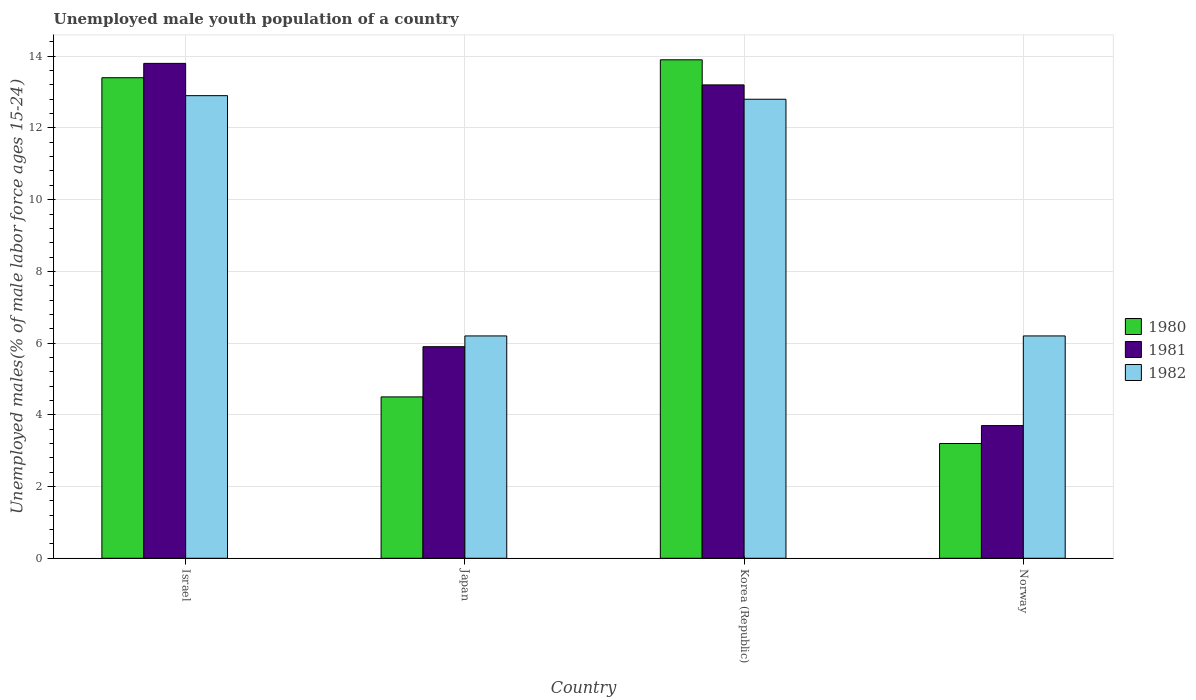How many different coloured bars are there?
Your answer should be compact. 3. Are the number of bars per tick equal to the number of legend labels?
Provide a short and direct response. Yes. Are the number of bars on each tick of the X-axis equal?
Offer a terse response. Yes. How many bars are there on the 1st tick from the left?
Your answer should be very brief. 3. How many bars are there on the 2nd tick from the right?
Keep it short and to the point. 3. What is the label of the 4th group of bars from the left?
Your answer should be compact. Norway. Across all countries, what is the maximum percentage of unemployed male youth population in 1982?
Offer a very short reply. 12.9. Across all countries, what is the minimum percentage of unemployed male youth population in 1980?
Provide a short and direct response. 3.2. What is the total percentage of unemployed male youth population in 1981 in the graph?
Make the answer very short. 36.6. What is the difference between the percentage of unemployed male youth population in 1982 in Israel and that in Japan?
Offer a very short reply. 6.7. What is the difference between the percentage of unemployed male youth population in 1982 in Japan and the percentage of unemployed male youth population in 1981 in Israel?
Offer a terse response. -7.6. What is the average percentage of unemployed male youth population in 1982 per country?
Provide a short and direct response. 9.52. What is the difference between the percentage of unemployed male youth population of/in 1982 and percentage of unemployed male youth population of/in 1981 in Japan?
Your answer should be very brief. 0.3. In how many countries, is the percentage of unemployed male youth population in 1982 greater than 10.4 %?
Offer a terse response. 2. What is the ratio of the percentage of unemployed male youth population in 1982 in Israel to that in Norway?
Keep it short and to the point. 2.08. What is the difference between the highest and the second highest percentage of unemployed male youth population in 1982?
Offer a terse response. 0.1. What is the difference between the highest and the lowest percentage of unemployed male youth population in 1980?
Ensure brevity in your answer.  10.7. What does the 2nd bar from the right in Korea (Republic) represents?
Make the answer very short. 1981. Is it the case that in every country, the sum of the percentage of unemployed male youth population in 1980 and percentage of unemployed male youth population in 1982 is greater than the percentage of unemployed male youth population in 1981?
Keep it short and to the point. Yes. Are all the bars in the graph horizontal?
Offer a terse response. No. What is the difference between two consecutive major ticks on the Y-axis?
Your answer should be compact. 2. Are the values on the major ticks of Y-axis written in scientific E-notation?
Make the answer very short. No. How many legend labels are there?
Keep it short and to the point. 3. What is the title of the graph?
Provide a succinct answer. Unemployed male youth population of a country. Does "1989" appear as one of the legend labels in the graph?
Your answer should be very brief. No. What is the label or title of the Y-axis?
Provide a short and direct response. Unemployed males(% of male labor force ages 15-24). What is the Unemployed males(% of male labor force ages 15-24) in 1980 in Israel?
Offer a very short reply. 13.4. What is the Unemployed males(% of male labor force ages 15-24) in 1981 in Israel?
Your answer should be very brief. 13.8. What is the Unemployed males(% of male labor force ages 15-24) of 1982 in Israel?
Provide a short and direct response. 12.9. What is the Unemployed males(% of male labor force ages 15-24) in 1981 in Japan?
Keep it short and to the point. 5.9. What is the Unemployed males(% of male labor force ages 15-24) of 1982 in Japan?
Your response must be concise. 6.2. What is the Unemployed males(% of male labor force ages 15-24) in 1980 in Korea (Republic)?
Offer a terse response. 13.9. What is the Unemployed males(% of male labor force ages 15-24) in 1981 in Korea (Republic)?
Ensure brevity in your answer.  13.2. What is the Unemployed males(% of male labor force ages 15-24) of 1982 in Korea (Republic)?
Make the answer very short. 12.8. What is the Unemployed males(% of male labor force ages 15-24) in 1980 in Norway?
Keep it short and to the point. 3.2. What is the Unemployed males(% of male labor force ages 15-24) in 1981 in Norway?
Make the answer very short. 3.7. What is the Unemployed males(% of male labor force ages 15-24) in 1982 in Norway?
Provide a short and direct response. 6.2. Across all countries, what is the maximum Unemployed males(% of male labor force ages 15-24) of 1980?
Keep it short and to the point. 13.9. Across all countries, what is the maximum Unemployed males(% of male labor force ages 15-24) of 1981?
Make the answer very short. 13.8. Across all countries, what is the maximum Unemployed males(% of male labor force ages 15-24) in 1982?
Your answer should be very brief. 12.9. Across all countries, what is the minimum Unemployed males(% of male labor force ages 15-24) of 1980?
Provide a succinct answer. 3.2. Across all countries, what is the minimum Unemployed males(% of male labor force ages 15-24) in 1981?
Ensure brevity in your answer.  3.7. Across all countries, what is the minimum Unemployed males(% of male labor force ages 15-24) in 1982?
Your response must be concise. 6.2. What is the total Unemployed males(% of male labor force ages 15-24) of 1981 in the graph?
Your response must be concise. 36.6. What is the total Unemployed males(% of male labor force ages 15-24) in 1982 in the graph?
Make the answer very short. 38.1. What is the difference between the Unemployed males(% of male labor force ages 15-24) in 1980 in Israel and that in Japan?
Ensure brevity in your answer.  8.9. What is the difference between the Unemployed males(% of male labor force ages 15-24) of 1982 in Israel and that in Korea (Republic)?
Your answer should be very brief. 0.1. What is the difference between the Unemployed males(% of male labor force ages 15-24) in 1982 in Japan and that in Korea (Republic)?
Offer a very short reply. -6.6. What is the difference between the Unemployed males(% of male labor force ages 15-24) of 1980 in Japan and that in Norway?
Your response must be concise. 1.3. What is the difference between the Unemployed males(% of male labor force ages 15-24) in 1981 in Japan and that in Norway?
Ensure brevity in your answer.  2.2. What is the difference between the Unemployed males(% of male labor force ages 15-24) in 1980 in Korea (Republic) and that in Norway?
Offer a very short reply. 10.7. What is the difference between the Unemployed males(% of male labor force ages 15-24) of 1981 in Korea (Republic) and that in Norway?
Your answer should be very brief. 9.5. What is the difference between the Unemployed males(% of male labor force ages 15-24) of 1980 in Israel and the Unemployed males(% of male labor force ages 15-24) of 1981 in Japan?
Keep it short and to the point. 7.5. What is the difference between the Unemployed males(% of male labor force ages 15-24) in 1980 in Israel and the Unemployed males(% of male labor force ages 15-24) in 1982 in Japan?
Your answer should be very brief. 7.2. What is the difference between the Unemployed males(% of male labor force ages 15-24) of 1980 in Israel and the Unemployed males(% of male labor force ages 15-24) of 1981 in Korea (Republic)?
Offer a terse response. 0.2. What is the difference between the Unemployed males(% of male labor force ages 15-24) of 1980 in Israel and the Unemployed males(% of male labor force ages 15-24) of 1982 in Korea (Republic)?
Ensure brevity in your answer.  0.6. What is the difference between the Unemployed males(% of male labor force ages 15-24) of 1981 in Israel and the Unemployed males(% of male labor force ages 15-24) of 1982 in Korea (Republic)?
Your response must be concise. 1. What is the difference between the Unemployed males(% of male labor force ages 15-24) of 1980 in Israel and the Unemployed males(% of male labor force ages 15-24) of 1982 in Norway?
Offer a very short reply. 7.2. What is the difference between the Unemployed males(% of male labor force ages 15-24) of 1981 in Israel and the Unemployed males(% of male labor force ages 15-24) of 1982 in Norway?
Your answer should be very brief. 7.6. What is the difference between the Unemployed males(% of male labor force ages 15-24) of 1980 in Japan and the Unemployed males(% of male labor force ages 15-24) of 1981 in Korea (Republic)?
Provide a succinct answer. -8.7. What is the difference between the Unemployed males(% of male labor force ages 15-24) of 1980 in Japan and the Unemployed males(% of male labor force ages 15-24) of 1981 in Norway?
Your answer should be very brief. 0.8. What is the average Unemployed males(% of male labor force ages 15-24) in 1980 per country?
Make the answer very short. 8.75. What is the average Unemployed males(% of male labor force ages 15-24) in 1981 per country?
Offer a terse response. 9.15. What is the average Unemployed males(% of male labor force ages 15-24) of 1982 per country?
Provide a succinct answer. 9.53. What is the difference between the Unemployed males(% of male labor force ages 15-24) of 1980 and Unemployed males(% of male labor force ages 15-24) of 1981 in Israel?
Offer a very short reply. -0.4. What is the difference between the Unemployed males(% of male labor force ages 15-24) of 1981 and Unemployed males(% of male labor force ages 15-24) of 1982 in Korea (Republic)?
Give a very brief answer. 0.4. What is the difference between the Unemployed males(% of male labor force ages 15-24) in 1980 and Unemployed males(% of male labor force ages 15-24) in 1981 in Norway?
Offer a terse response. -0.5. What is the difference between the Unemployed males(% of male labor force ages 15-24) in 1980 and Unemployed males(% of male labor force ages 15-24) in 1982 in Norway?
Ensure brevity in your answer.  -3. What is the difference between the Unemployed males(% of male labor force ages 15-24) of 1981 and Unemployed males(% of male labor force ages 15-24) of 1982 in Norway?
Offer a very short reply. -2.5. What is the ratio of the Unemployed males(% of male labor force ages 15-24) in 1980 in Israel to that in Japan?
Provide a succinct answer. 2.98. What is the ratio of the Unemployed males(% of male labor force ages 15-24) of 1981 in Israel to that in Japan?
Your answer should be compact. 2.34. What is the ratio of the Unemployed males(% of male labor force ages 15-24) in 1982 in Israel to that in Japan?
Offer a very short reply. 2.08. What is the ratio of the Unemployed males(% of male labor force ages 15-24) in 1980 in Israel to that in Korea (Republic)?
Provide a succinct answer. 0.96. What is the ratio of the Unemployed males(% of male labor force ages 15-24) in 1981 in Israel to that in Korea (Republic)?
Ensure brevity in your answer.  1.05. What is the ratio of the Unemployed males(% of male labor force ages 15-24) of 1982 in Israel to that in Korea (Republic)?
Make the answer very short. 1.01. What is the ratio of the Unemployed males(% of male labor force ages 15-24) in 1980 in Israel to that in Norway?
Give a very brief answer. 4.19. What is the ratio of the Unemployed males(% of male labor force ages 15-24) in 1981 in Israel to that in Norway?
Your answer should be very brief. 3.73. What is the ratio of the Unemployed males(% of male labor force ages 15-24) of 1982 in Israel to that in Norway?
Your answer should be compact. 2.08. What is the ratio of the Unemployed males(% of male labor force ages 15-24) in 1980 in Japan to that in Korea (Republic)?
Provide a succinct answer. 0.32. What is the ratio of the Unemployed males(% of male labor force ages 15-24) in 1981 in Japan to that in Korea (Republic)?
Your response must be concise. 0.45. What is the ratio of the Unemployed males(% of male labor force ages 15-24) of 1982 in Japan to that in Korea (Republic)?
Keep it short and to the point. 0.48. What is the ratio of the Unemployed males(% of male labor force ages 15-24) in 1980 in Japan to that in Norway?
Your answer should be very brief. 1.41. What is the ratio of the Unemployed males(% of male labor force ages 15-24) of 1981 in Japan to that in Norway?
Offer a very short reply. 1.59. What is the ratio of the Unemployed males(% of male labor force ages 15-24) of 1980 in Korea (Republic) to that in Norway?
Provide a short and direct response. 4.34. What is the ratio of the Unemployed males(% of male labor force ages 15-24) in 1981 in Korea (Republic) to that in Norway?
Keep it short and to the point. 3.57. What is the ratio of the Unemployed males(% of male labor force ages 15-24) of 1982 in Korea (Republic) to that in Norway?
Keep it short and to the point. 2.06. What is the difference between the highest and the second highest Unemployed males(% of male labor force ages 15-24) of 1981?
Offer a very short reply. 0.6. 